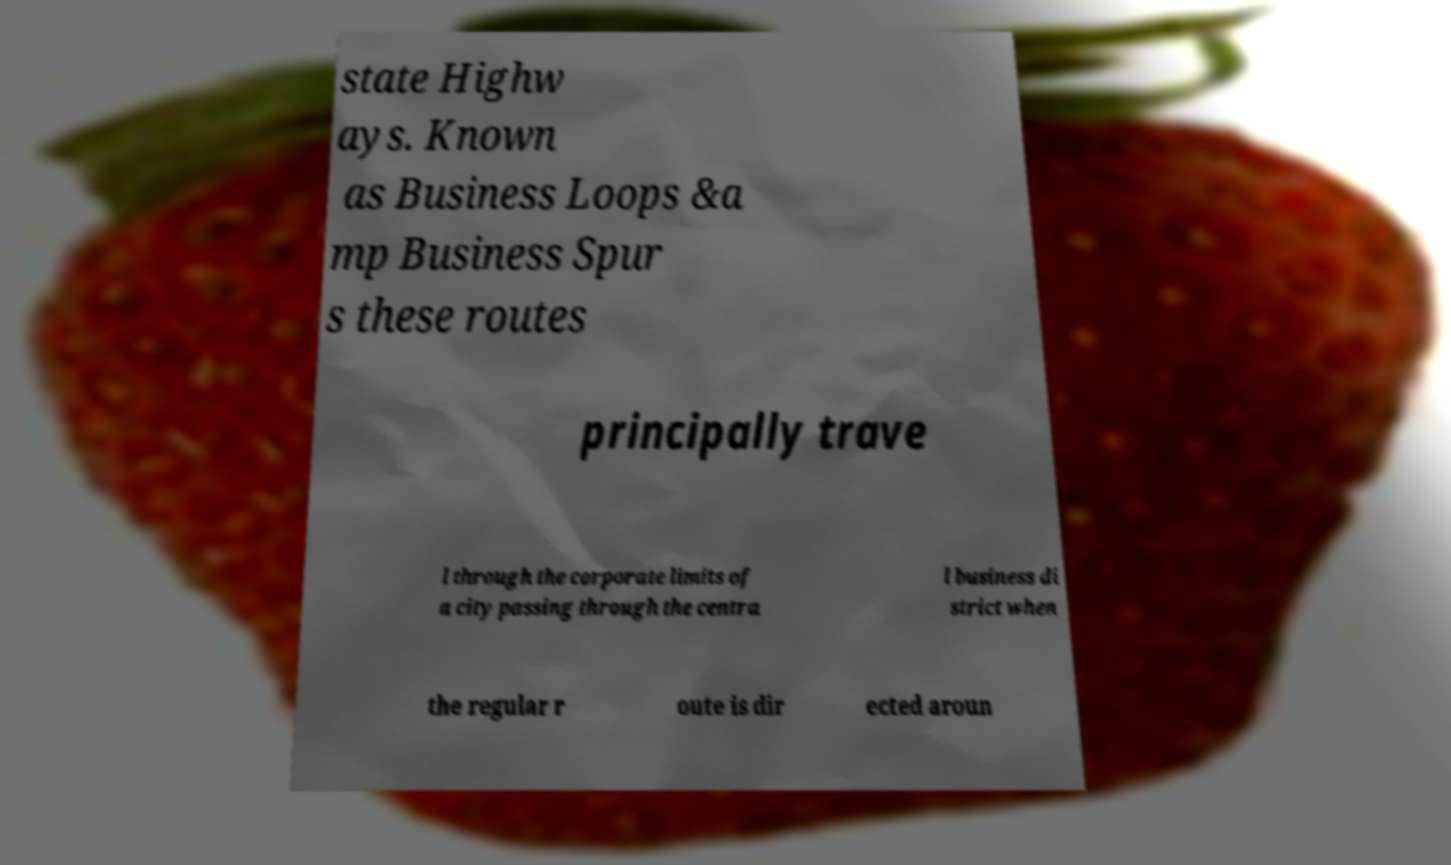Can you read and provide the text displayed in the image?This photo seems to have some interesting text. Can you extract and type it out for me? state Highw ays. Known as Business Loops &a mp Business Spur s these routes principally trave l through the corporate limits of a city passing through the centra l business di strict when the regular r oute is dir ected aroun 